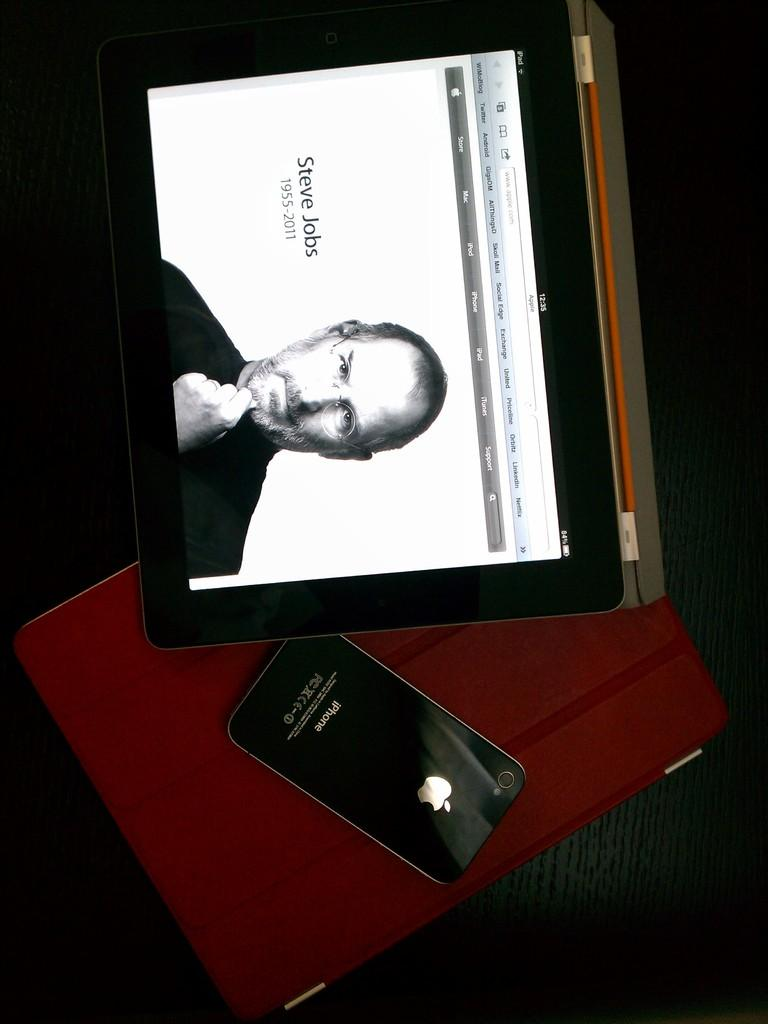<image>
Render a clear and concise summary of the photo. Black iPhone next to an iPad showing a screen with Steve Jobs. 